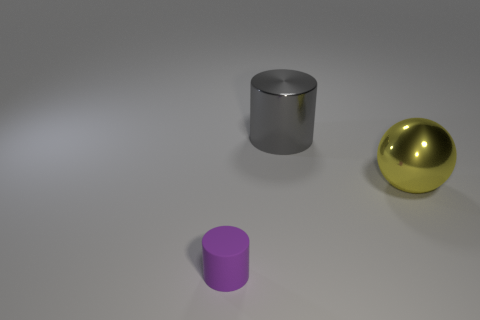Add 1 blue metal blocks. How many objects exist? 4 Subtract all balls. How many objects are left? 2 Subtract 0 red cylinders. How many objects are left? 3 Subtract all shiny cylinders. Subtract all gray objects. How many objects are left? 1 Add 2 big gray metal objects. How many big gray metal objects are left? 3 Add 1 big cylinders. How many big cylinders exist? 2 